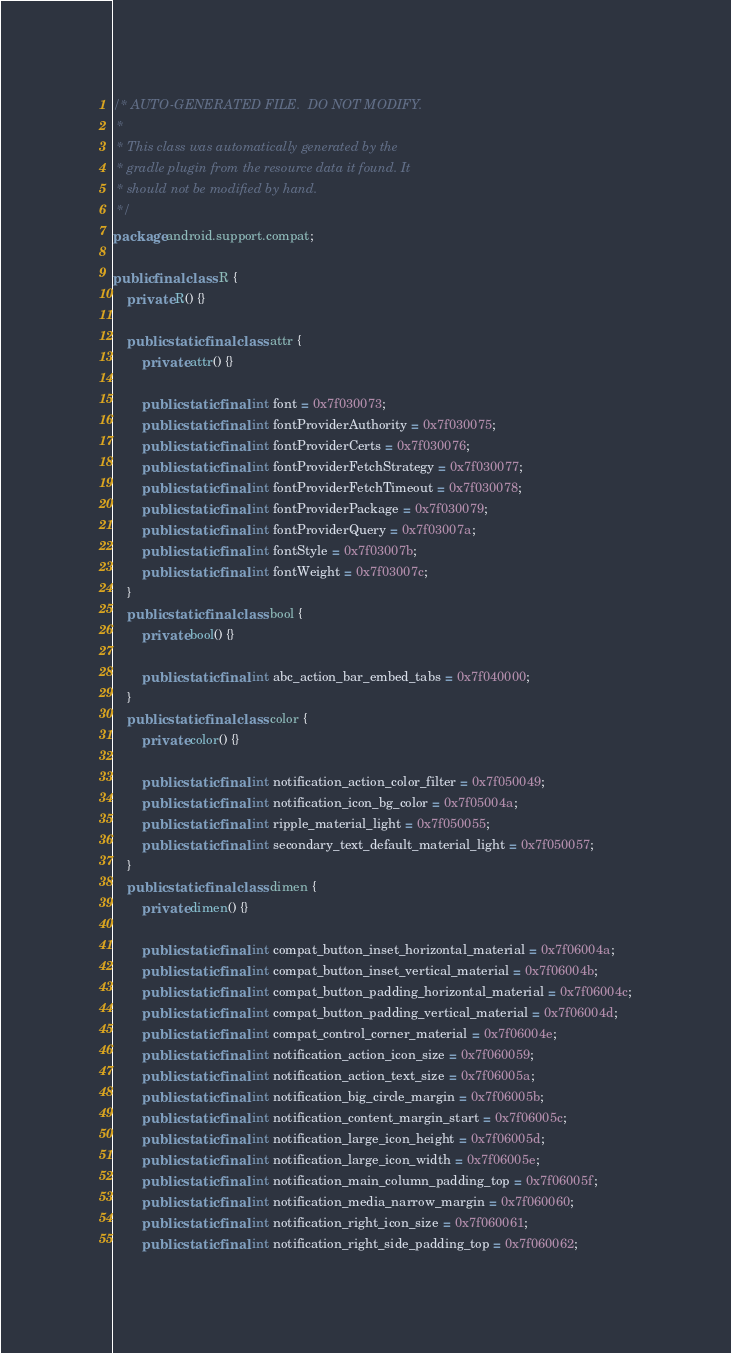Convert code to text. <code><loc_0><loc_0><loc_500><loc_500><_Java_>/* AUTO-GENERATED FILE.  DO NOT MODIFY.
 *
 * This class was automatically generated by the
 * gradle plugin from the resource data it found. It
 * should not be modified by hand.
 */
package android.support.compat;

public final class R {
    private R() {}

    public static final class attr {
        private attr() {}

        public static final int font = 0x7f030073;
        public static final int fontProviderAuthority = 0x7f030075;
        public static final int fontProviderCerts = 0x7f030076;
        public static final int fontProviderFetchStrategy = 0x7f030077;
        public static final int fontProviderFetchTimeout = 0x7f030078;
        public static final int fontProviderPackage = 0x7f030079;
        public static final int fontProviderQuery = 0x7f03007a;
        public static final int fontStyle = 0x7f03007b;
        public static final int fontWeight = 0x7f03007c;
    }
    public static final class bool {
        private bool() {}

        public static final int abc_action_bar_embed_tabs = 0x7f040000;
    }
    public static final class color {
        private color() {}

        public static final int notification_action_color_filter = 0x7f050049;
        public static final int notification_icon_bg_color = 0x7f05004a;
        public static final int ripple_material_light = 0x7f050055;
        public static final int secondary_text_default_material_light = 0x7f050057;
    }
    public static final class dimen {
        private dimen() {}

        public static final int compat_button_inset_horizontal_material = 0x7f06004a;
        public static final int compat_button_inset_vertical_material = 0x7f06004b;
        public static final int compat_button_padding_horizontal_material = 0x7f06004c;
        public static final int compat_button_padding_vertical_material = 0x7f06004d;
        public static final int compat_control_corner_material = 0x7f06004e;
        public static final int notification_action_icon_size = 0x7f060059;
        public static final int notification_action_text_size = 0x7f06005a;
        public static final int notification_big_circle_margin = 0x7f06005b;
        public static final int notification_content_margin_start = 0x7f06005c;
        public static final int notification_large_icon_height = 0x7f06005d;
        public static final int notification_large_icon_width = 0x7f06005e;
        public static final int notification_main_column_padding_top = 0x7f06005f;
        public static final int notification_media_narrow_margin = 0x7f060060;
        public static final int notification_right_icon_size = 0x7f060061;
        public static final int notification_right_side_padding_top = 0x7f060062;</code> 